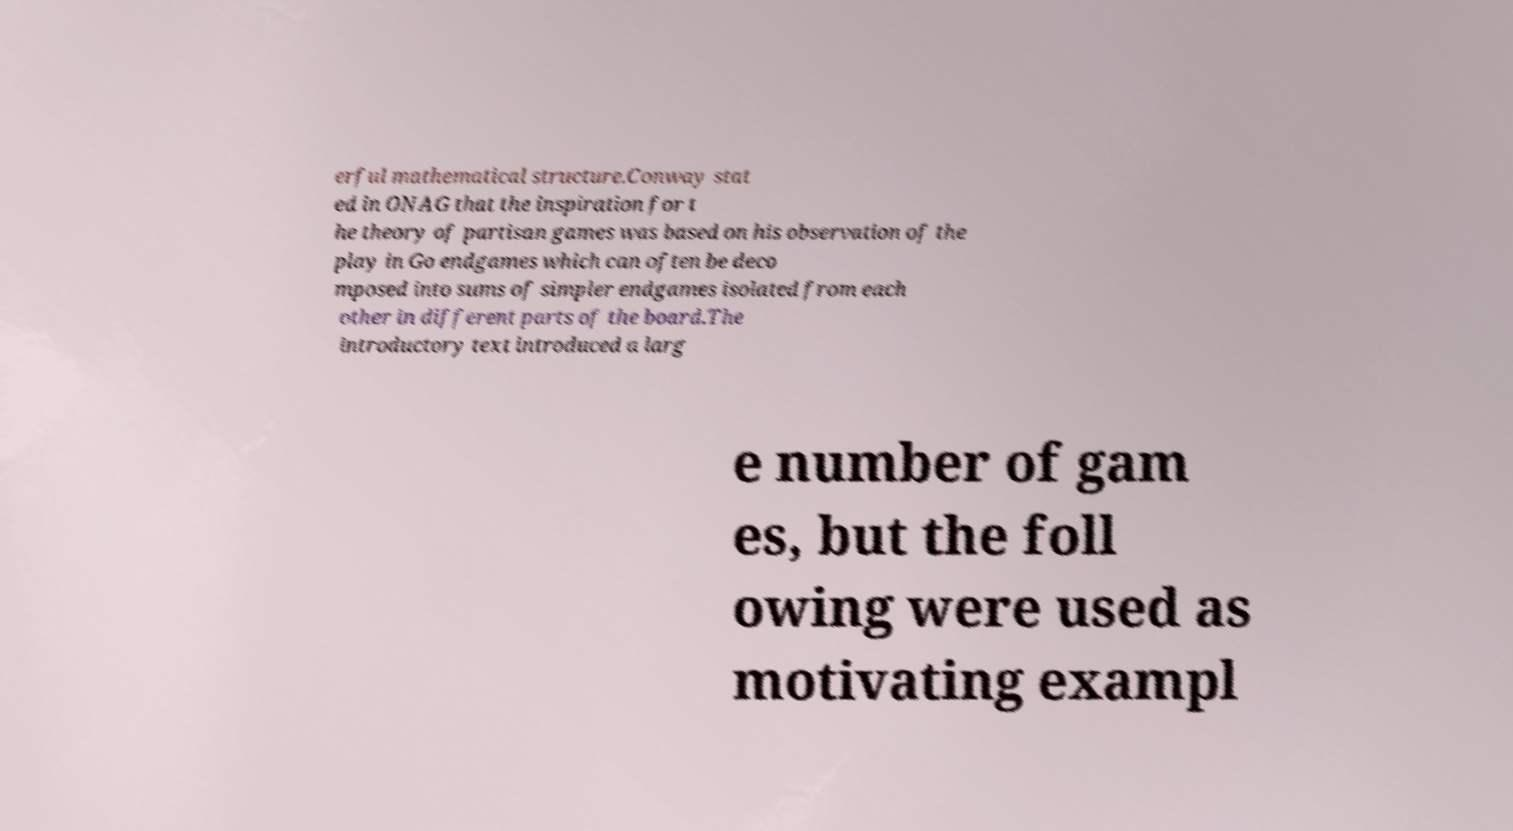Could you assist in decoding the text presented in this image and type it out clearly? erful mathematical structure.Conway stat ed in ONAG that the inspiration for t he theory of partisan games was based on his observation of the play in Go endgames which can often be deco mposed into sums of simpler endgames isolated from each other in different parts of the board.The introductory text introduced a larg e number of gam es, but the foll owing were used as motivating exampl 